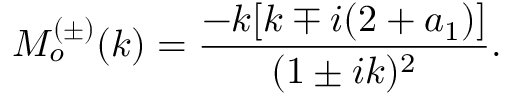<formula> <loc_0><loc_0><loc_500><loc_500>M _ { o } ^ { ( \pm ) } ( k ) = \frac { - k [ k \mp i ( 2 + a _ { 1 } ) ] } { ( 1 \pm i k ) ^ { 2 } } .</formula> 